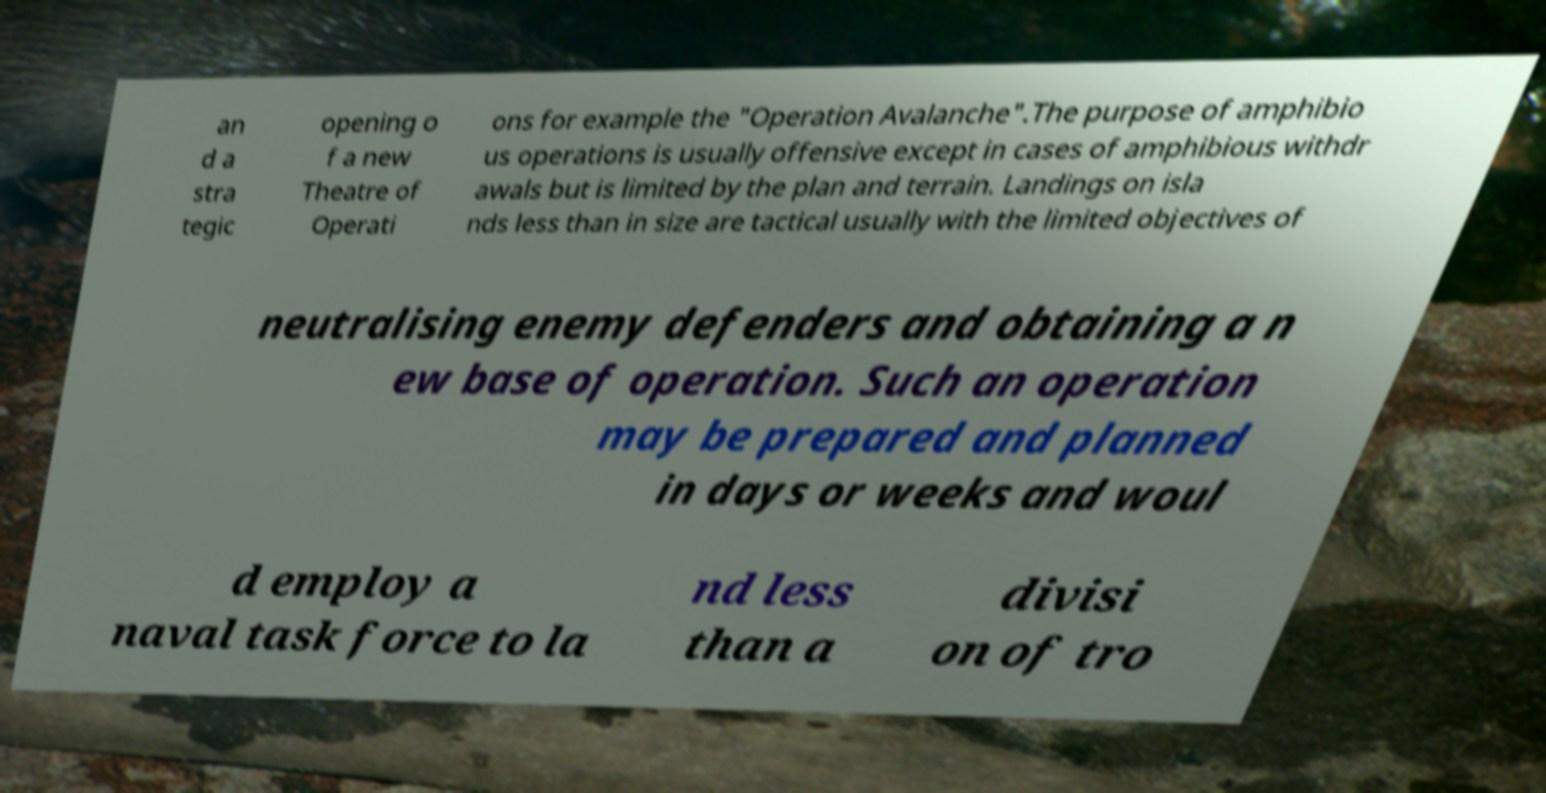Can you accurately transcribe the text from the provided image for me? an d a stra tegic opening o f a new Theatre of Operati ons for example the "Operation Avalanche".The purpose of amphibio us operations is usually offensive except in cases of amphibious withdr awals but is limited by the plan and terrain. Landings on isla nds less than in size are tactical usually with the limited objectives of neutralising enemy defenders and obtaining a n ew base of operation. Such an operation may be prepared and planned in days or weeks and woul d employ a naval task force to la nd less than a divisi on of tro 